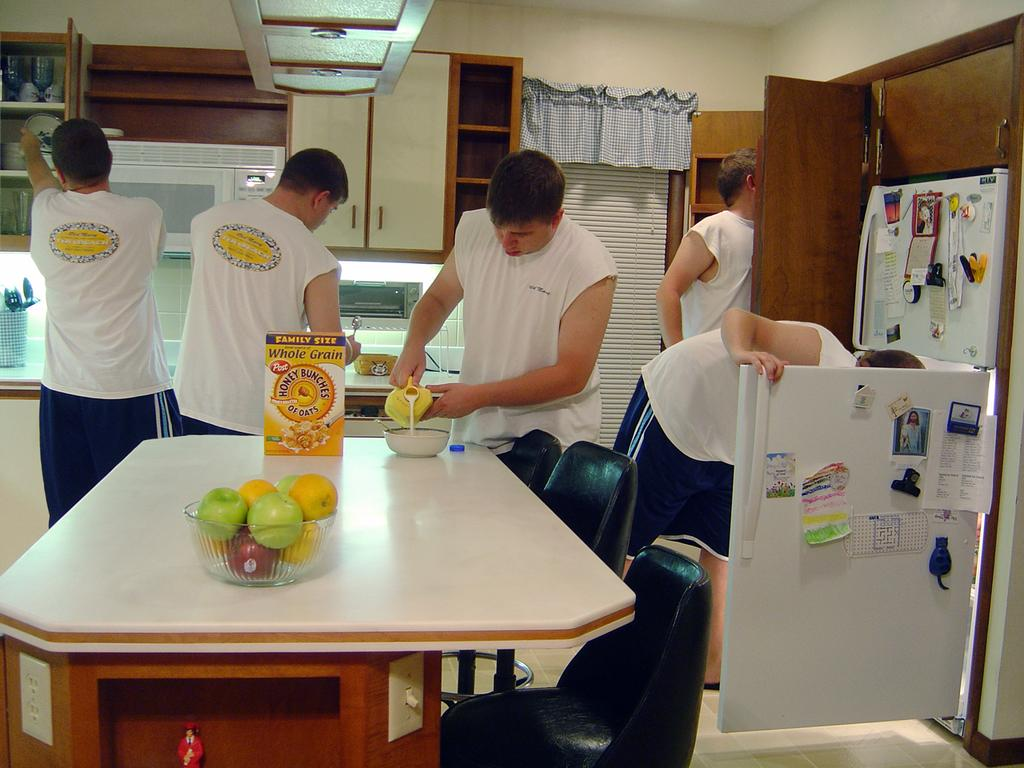<image>
Create a compact narrative representing the image presented. The type of cereal on the table is Honey Bunches of Oats 